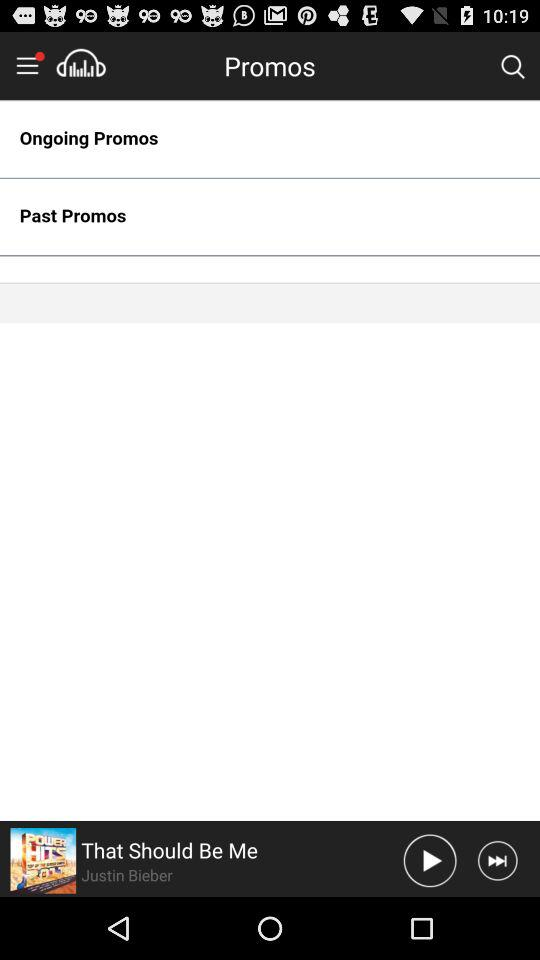How many ongoing promotions are there?
When the provided information is insufficient, respond with <no answer>. <no answer> 